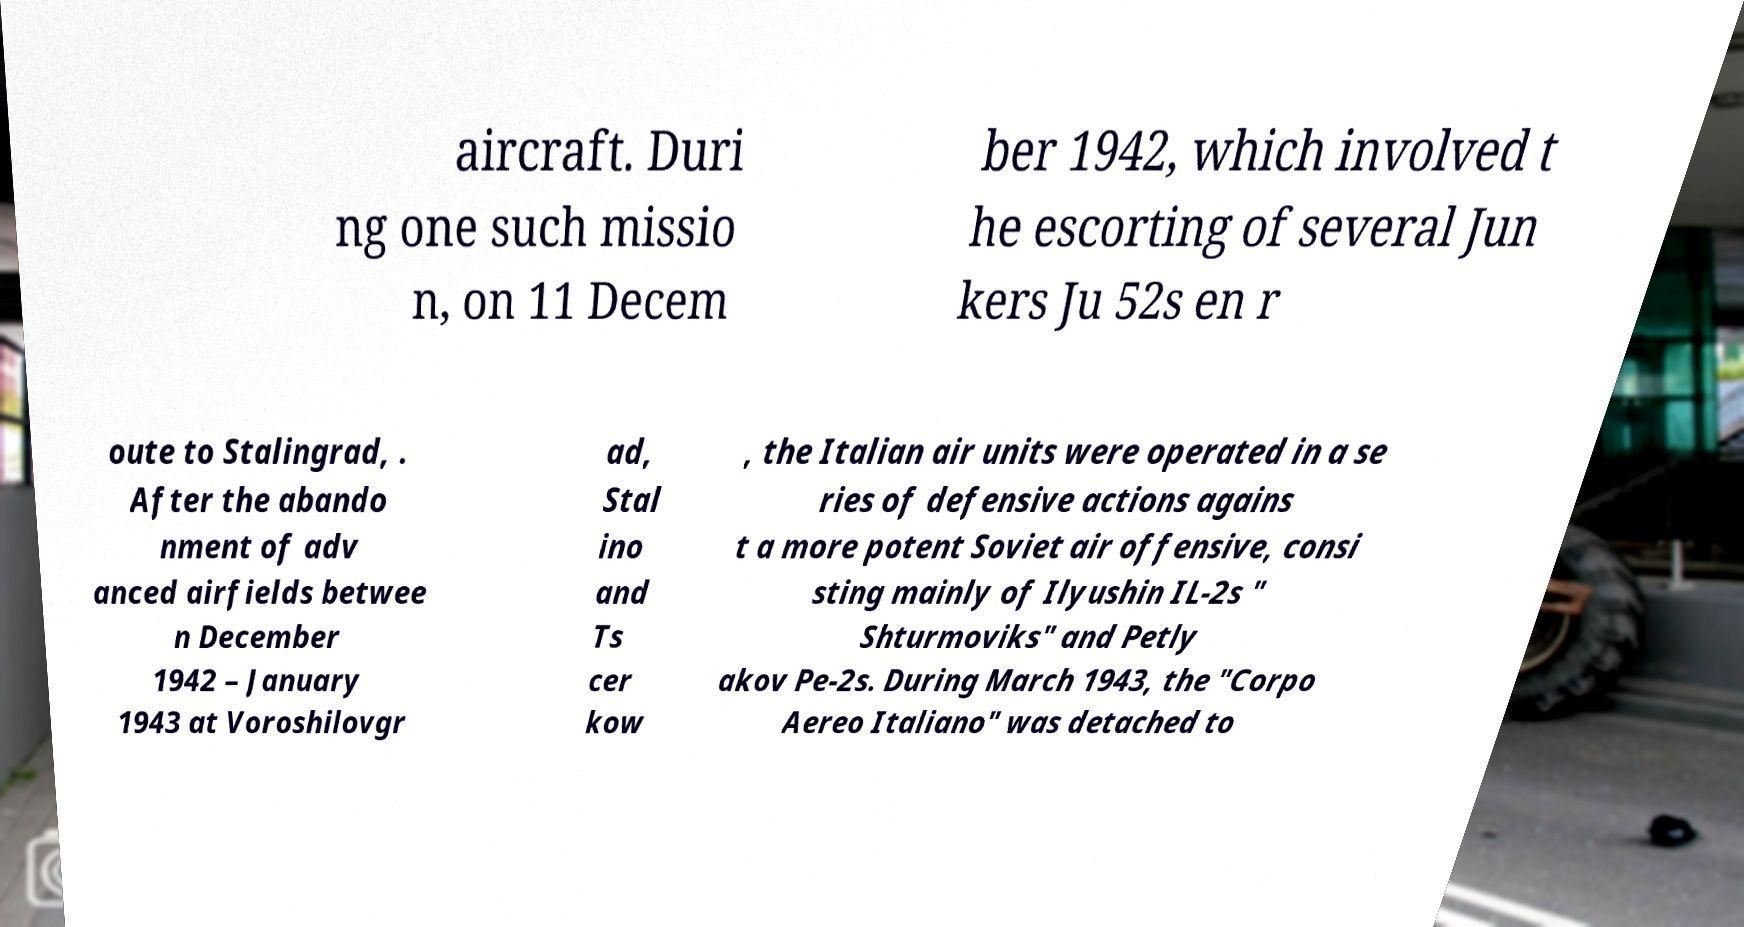What messages or text are displayed in this image? I need them in a readable, typed format. aircraft. Duri ng one such missio n, on 11 Decem ber 1942, which involved t he escorting of several Jun kers Ju 52s en r oute to Stalingrad, . After the abando nment of adv anced airfields betwee n December 1942 – January 1943 at Voroshilovgr ad, Stal ino and Ts cer kow , the Italian air units were operated in a se ries of defensive actions agains t a more potent Soviet air offensive, consi sting mainly of Ilyushin IL-2s " Shturmoviks" and Petly akov Pe-2s. During March 1943, the "Corpo Aereo Italiano" was detached to 